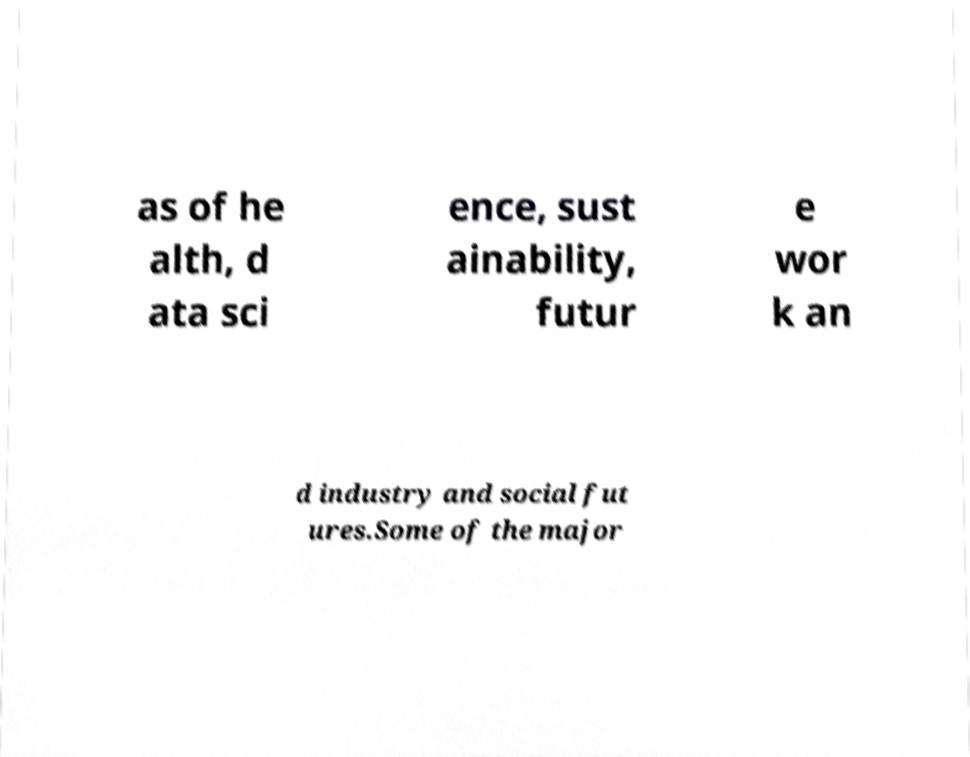Please identify and transcribe the text found in this image. as of he alth, d ata sci ence, sust ainability, futur e wor k an d industry and social fut ures.Some of the major 